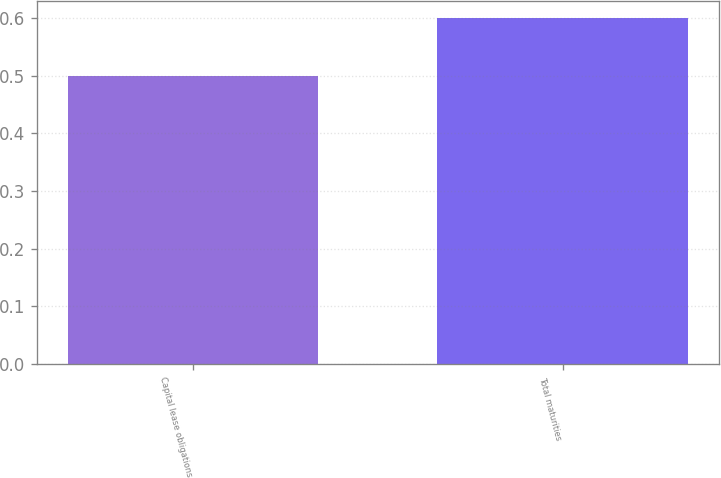<chart> <loc_0><loc_0><loc_500><loc_500><bar_chart><fcel>Capital lease obligations<fcel>Total maturities<nl><fcel>0.5<fcel>0.6<nl></chart> 